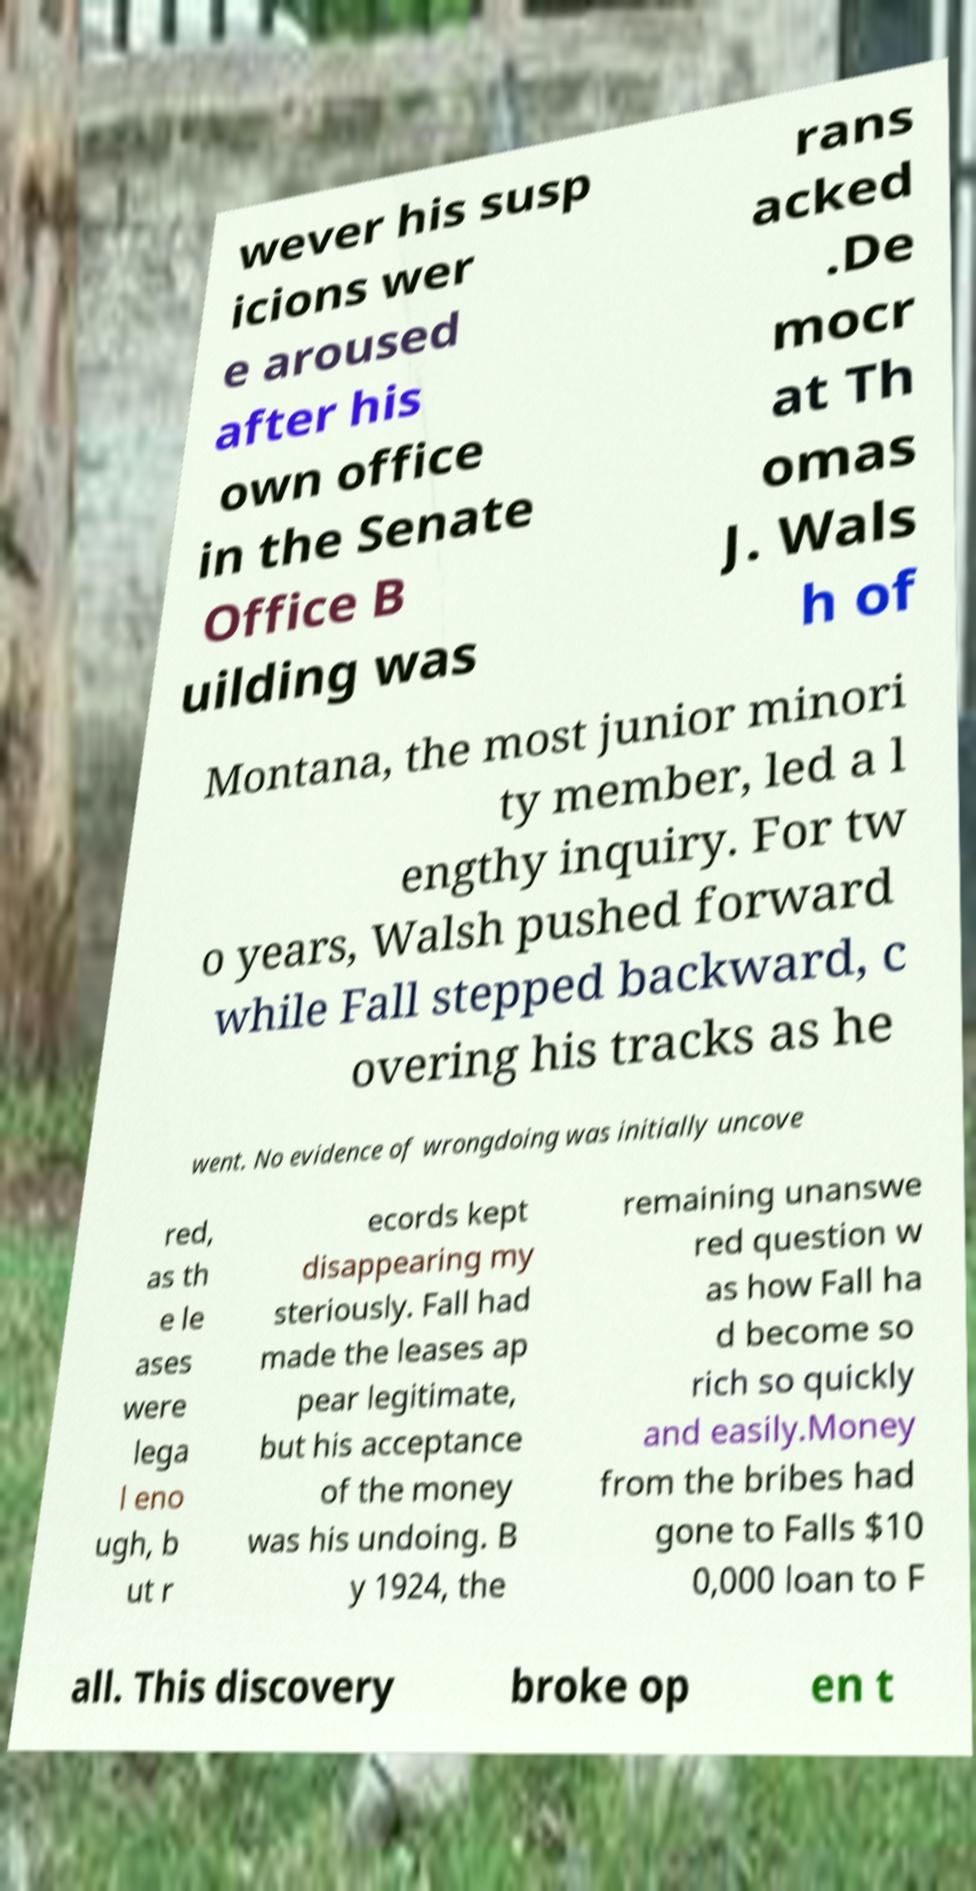What messages or text are displayed in this image? I need them in a readable, typed format. wever his susp icions wer e aroused after his own office in the Senate Office B uilding was rans acked .De mocr at Th omas J. Wals h of Montana, the most junior minori ty member, led a l engthy inquiry. For tw o years, Walsh pushed forward while Fall stepped backward, c overing his tracks as he went. No evidence of wrongdoing was initially uncove red, as th e le ases were lega l eno ugh, b ut r ecords kept disappearing my steriously. Fall had made the leases ap pear legitimate, but his acceptance of the money was his undoing. B y 1924, the remaining unanswe red question w as how Fall ha d become so rich so quickly and easily.Money from the bribes had gone to Falls $10 0,000 loan to F all. This discovery broke op en t 